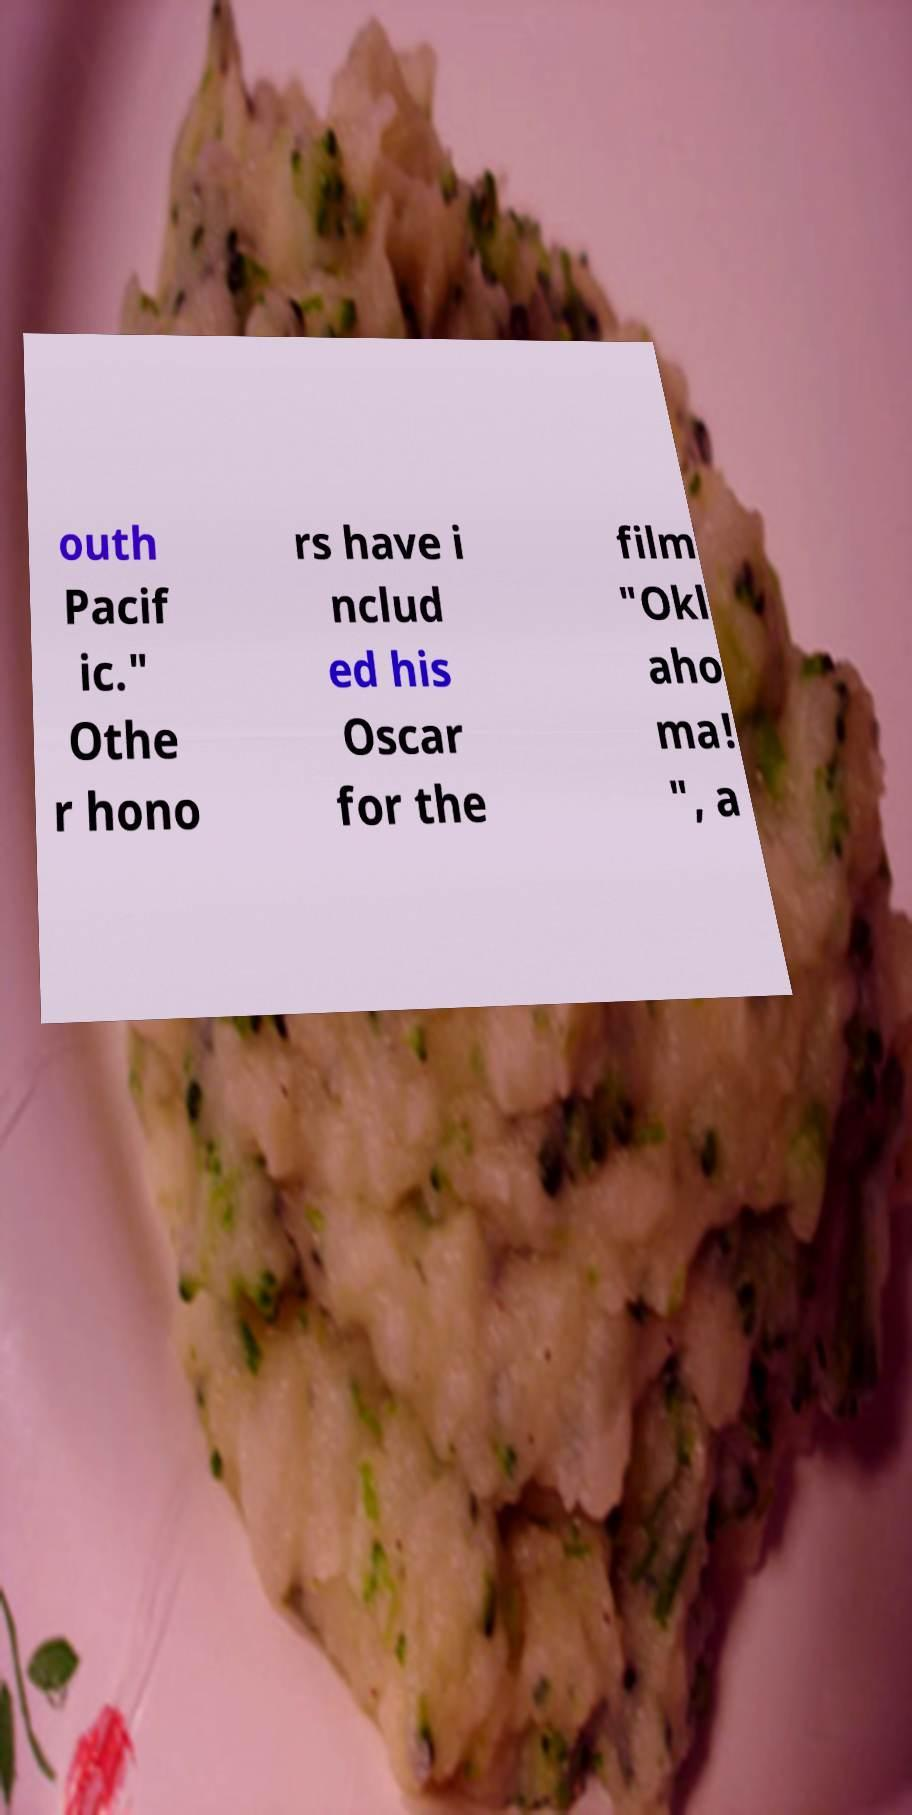Can you accurately transcribe the text from the provided image for me? outh Pacif ic." Othe r hono rs have i nclud ed his Oscar for the film "Okl aho ma! ", a 